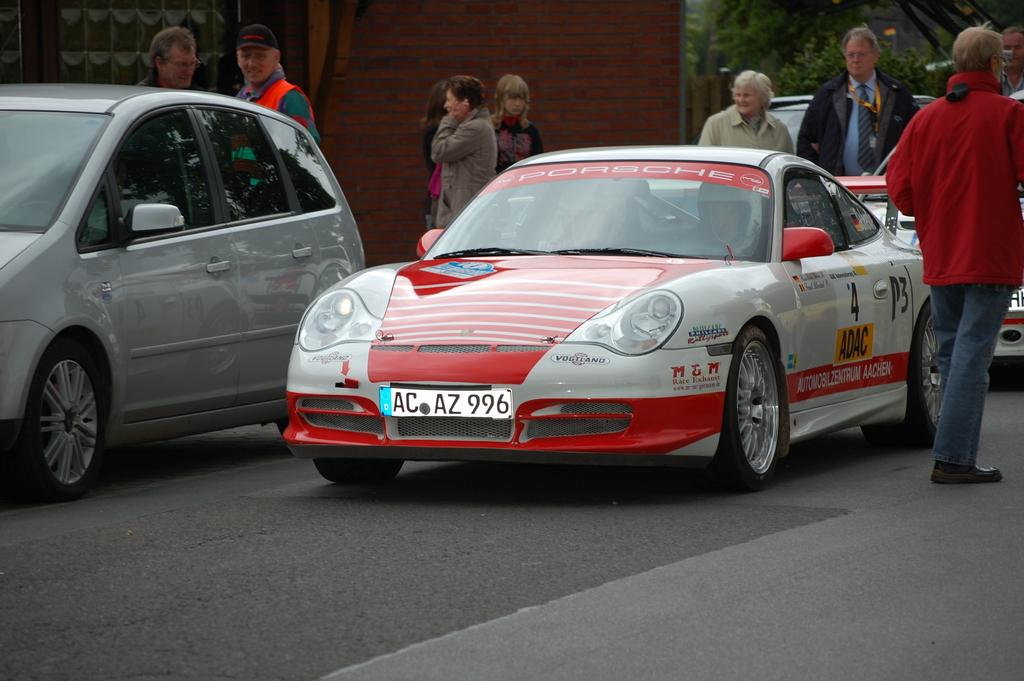What can be seen on the road in the image? There are vehicles on the road in the image. What else is present in the image besides the vehicles? There is a group of people standing in the image. What can be seen in the distance in the image? There are trees in the background of the image. What type of education is being provided to the ghost in the image? There is no ghost present in the image, so it is not possible to determine if any education is being provided. 